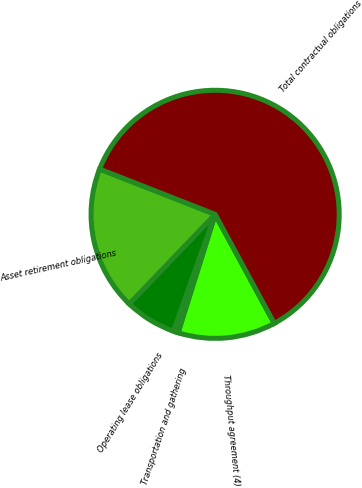Convert chart to OTSL. <chart><loc_0><loc_0><loc_500><loc_500><pie_chart><fcel>Throughput agreement (4)<fcel>Transportation and gathering<fcel>Operating lease obligations<fcel>Asset retirement obligations<fcel>Total contractual obligations<nl><fcel>12.74%<fcel>0.64%<fcel>6.69%<fcel>18.79%<fcel>61.14%<nl></chart> 